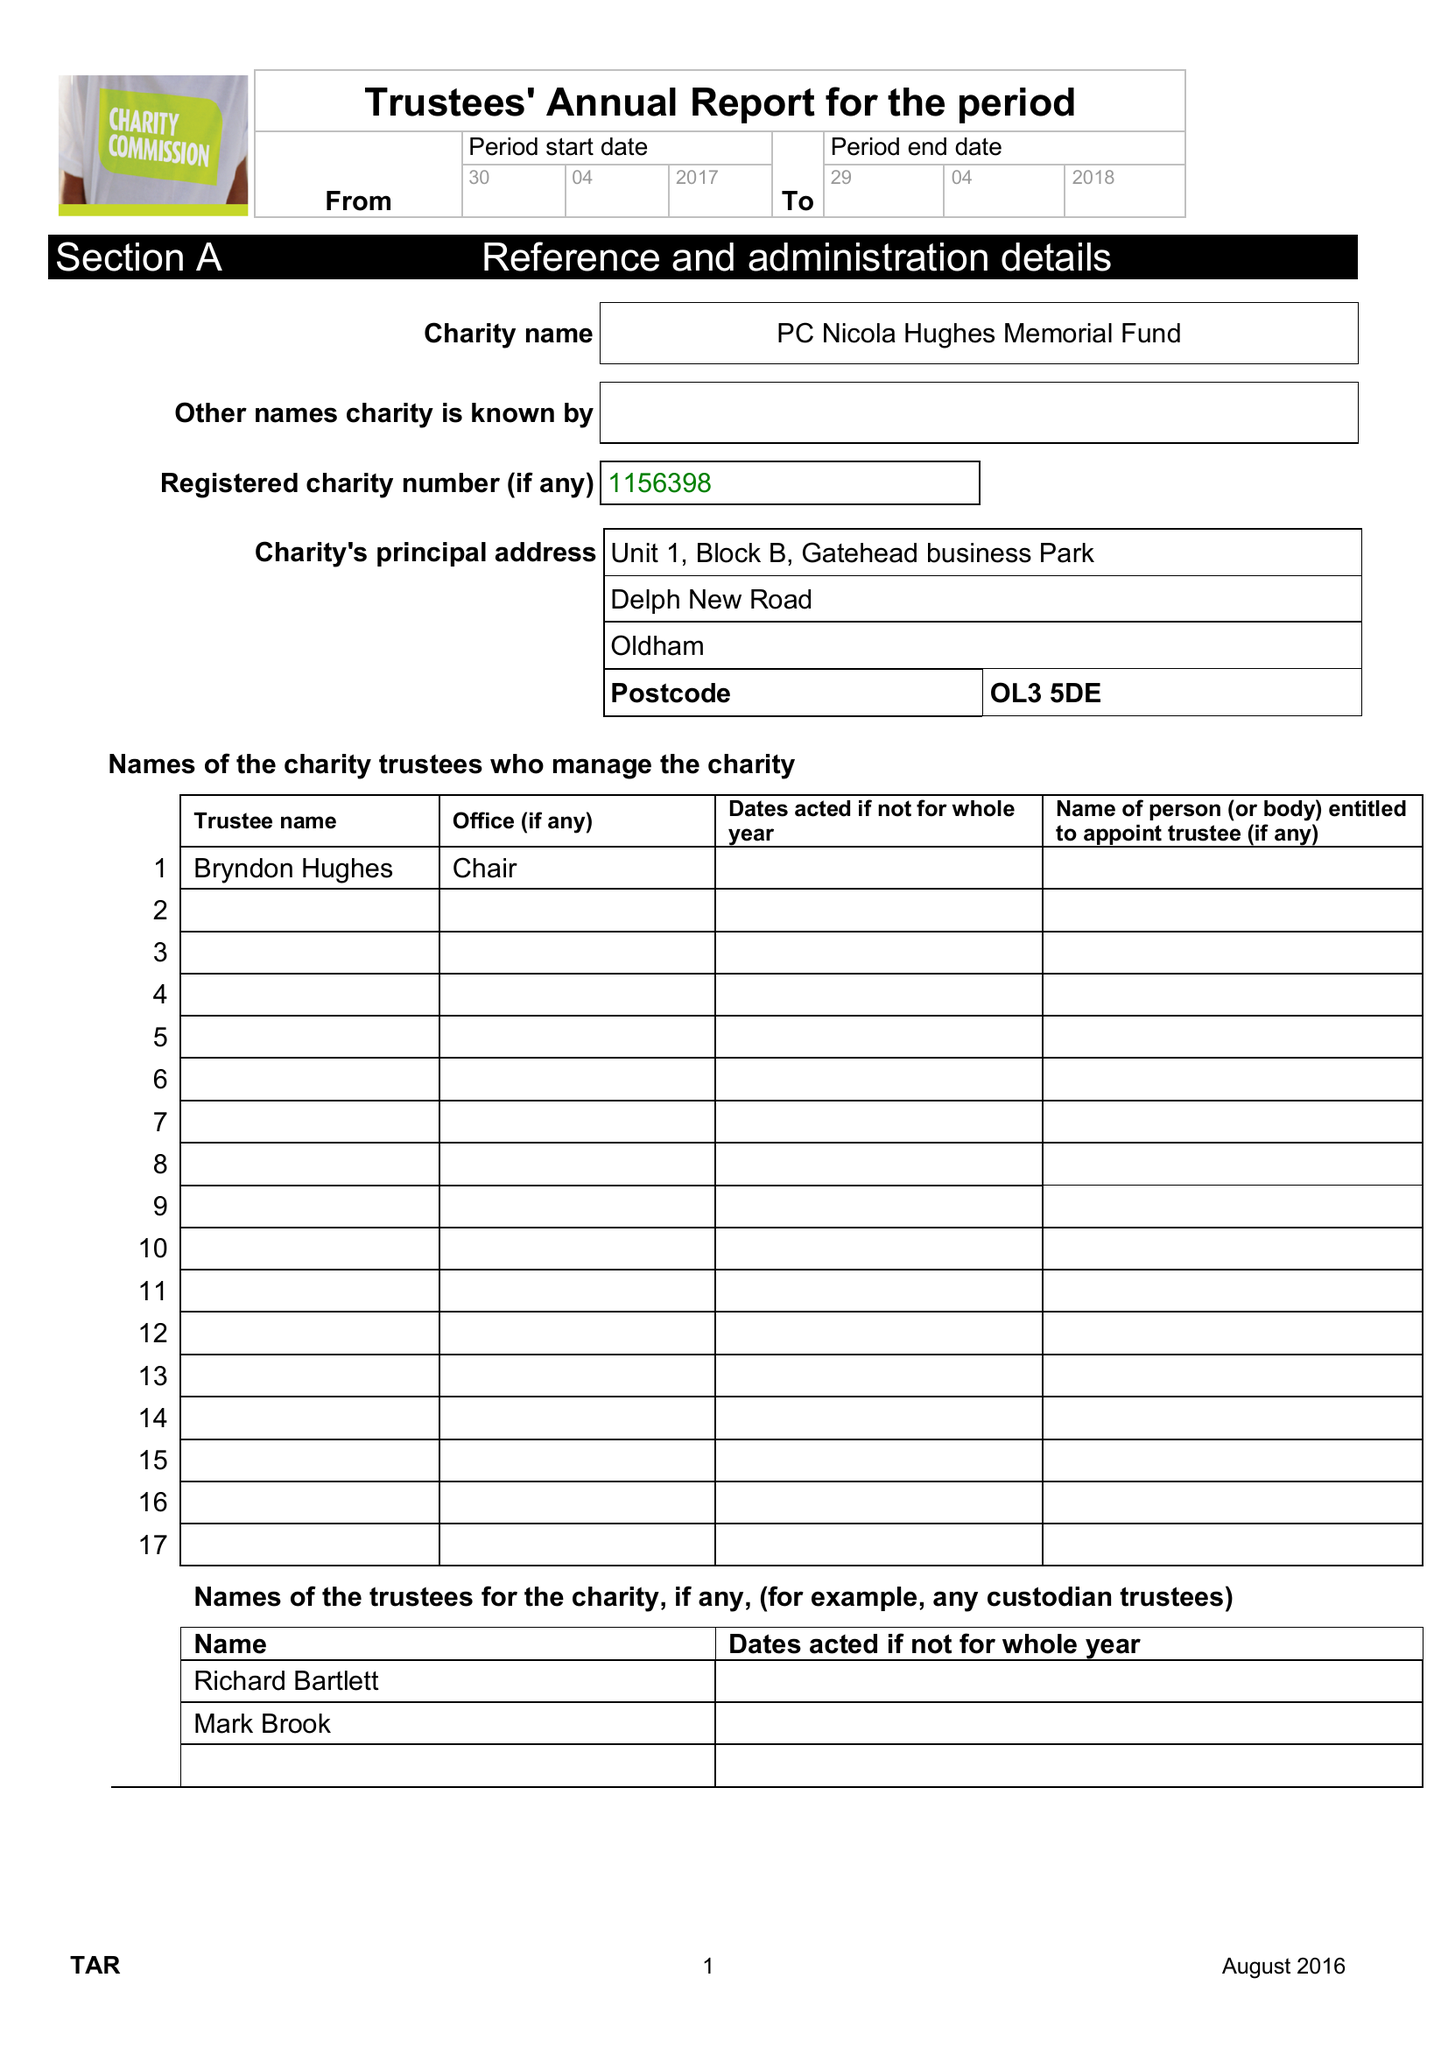What is the value for the report_date?
Answer the question using a single word or phrase. 2018-04-29 